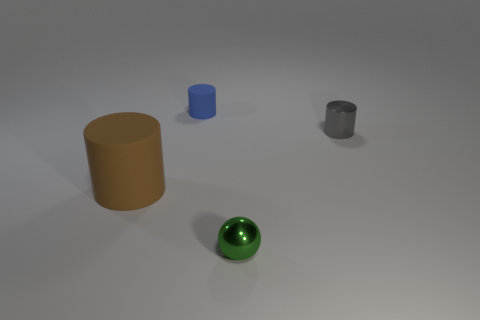Add 1 small purple things. How many objects exist? 5 Subtract all cylinders. How many objects are left? 1 Subtract all purple blocks. Subtract all small things. How many objects are left? 1 Add 4 small metallic things. How many small metallic things are left? 6 Add 2 blocks. How many blocks exist? 2 Subtract 0 yellow balls. How many objects are left? 4 